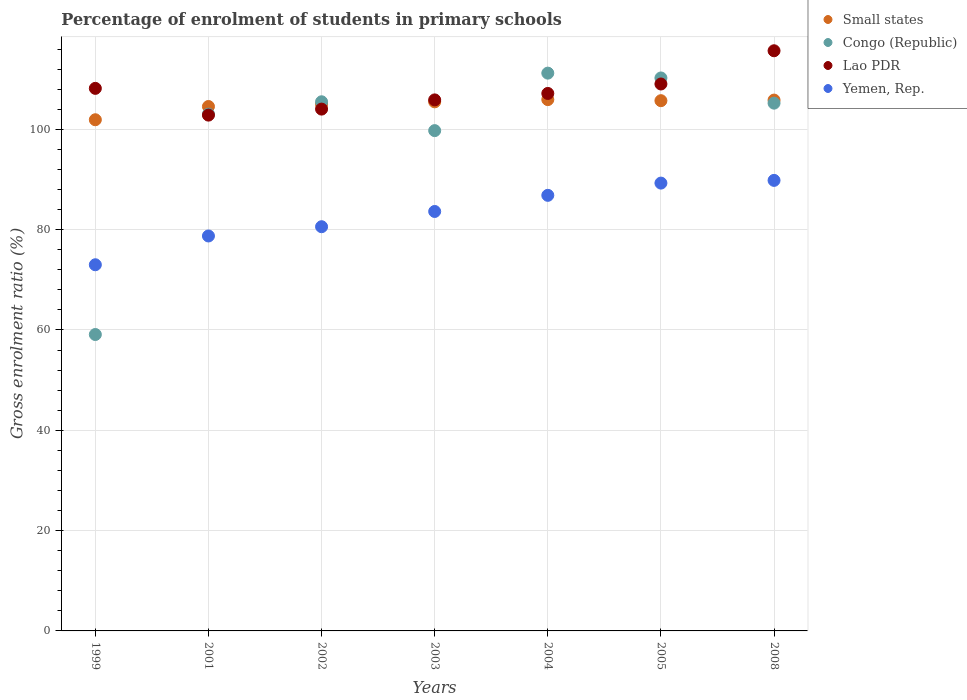Is the number of dotlines equal to the number of legend labels?
Provide a succinct answer. Yes. What is the percentage of students enrolled in primary schools in Lao PDR in 2008?
Your answer should be very brief. 115.67. Across all years, what is the maximum percentage of students enrolled in primary schools in Small states?
Provide a short and direct response. 105.93. Across all years, what is the minimum percentage of students enrolled in primary schools in Lao PDR?
Make the answer very short. 102.84. In which year was the percentage of students enrolled in primary schools in Lao PDR minimum?
Offer a very short reply. 2001. What is the total percentage of students enrolled in primary schools in Lao PDR in the graph?
Offer a very short reply. 752.82. What is the difference between the percentage of students enrolled in primary schools in Small states in 2002 and that in 2005?
Your response must be concise. -0.71. What is the difference between the percentage of students enrolled in primary schools in Congo (Republic) in 2004 and the percentage of students enrolled in primary schools in Lao PDR in 2003?
Ensure brevity in your answer.  5.34. What is the average percentage of students enrolled in primary schools in Congo (Republic) per year?
Ensure brevity in your answer.  99.16. In the year 2005, what is the difference between the percentage of students enrolled in primary schools in Lao PDR and percentage of students enrolled in primary schools in Small states?
Your response must be concise. 3.33. In how many years, is the percentage of students enrolled in primary schools in Small states greater than 24 %?
Offer a very short reply. 7. What is the ratio of the percentage of students enrolled in primary schools in Lao PDR in 2001 to that in 2005?
Keep it short and to the point. 0.94. What is the difference between the highest and the second highest percentage of students enrolled in primary schools in Small states?
Make the answer very short. 0.09. What is the difference between the highest and the lowest percentage of students enrolled in primary schools in Congo (Republic)?
Make the answer very short. 52.12. In how many years, is the percentage of students enrolled in primary schools in Small states greater than the average percentage of students enrolled in primary schools in Small states taken over all years?
Give a very brief answer. 5. Is the sum of the percentage of students enrolled in primary schools in Lao PDR in 1999 and 2001 greater than the maximum percentage of students enrolled in primary schools in Yemen, Rep. across all years?
Make the answer very short. Yes. Is it the case that in every year, the sum of the percentage of students enrolled in primary schools in Congo (Republic) and percentage of students enrolled in primary schools in Yemen, Rep.  is greater than the sum of percentage of students enrolled in primary schools in Small states and percentage of students enrolled in primary schools in Lao PDR?
Your response must be concise. No. Is it the case that in every year, the sum of the percentage of students enrolled in primary schools in Yemen, Rep. and percentage of students enrolled in primary schools in Lao PDR  is greater than the percentage of students enrolled in primary schools in Congo (Republic)?
Offer a terse response. Yes. Does the percentage of students enrolled in primary schools in Lao PDR monotonically increase over the years?
Provide a short and direct response. No. Is the percentage of students enrolled in primary schools in Congo (Republic) strictly greater than the percentage of students enrolled in primary schools in Small states over the years?
Ensure brevity in your answer.  No. What is the difference between two consecutive major ticks on the Y-axis?
Provide a succinct answer. 20. Where does the legend appear in the graph?
Make the answer very short. Top right. How many legend labels are there?
Offer a very short reply. 4. What is the title of the graph?
Keep it short and to the point. Percentage of enrolment of students in primary schools. What is the label or title of the X-axis?
Give a very brief answer. Years. What is the Gross enrolment ratio (%) in Small states in 1999?
Give a very brief answer. 101.92. What is the Gross enrolment ratio (%) in Congo (Republic) in 1999?
Keep it short and to the point. 59.1. What is the Gross enrolment ratio (%) of Lao PDR in 1999?
Keep it short and to the point. 108.18. What is the Gross enrolment ratio (%) of Yemen, Rep. in 1999?
Offer a very short reply. 73.01. What is the Gross enrolment ratio (%) of Small states in 2001?
Your answer should be compact. 104.56. What is the Gross enrolment ratio (%) in Congo (Republic) in 2001?
Give a very brief answer. 103.04. What is the Gross enrolment ratio (%) in Lao PDR in 2001?
Make the answer very short. 102.84. What is the Gross enrolment ratio (%) in Yemen, Rep. in 2001?
Provide a succinct answer. 78.75. What is the Gross enrolment ratio (%) of Small states in 2002?
Ensure brevity in your answer.  105.01. What is the Gross enrolment ratio (%) in Congo (Republic) in 2002?
Give a very brief answer. 105.5. What is the Gross enrolment ratio (%) of Lao PDR in 2002?
Offer a terse response. 104.04. What is the Gross enrolment ratio (%) in Yemen, Rep. in 2002?
Your response must be concise. 80.59. What is the Gross enrolment ratio (%) of Small states in 2003?
Keep it short and to the point. 105.49. What is the Gross enrolment ratio (%) of Congo (Republic) in 2003?
Your answer should be very brief. 99.75. What is the Gross enrolment ratio (%) of Lao PDR in 2003?
Keep it short and to the point. 105.88. What is the Gross enrolment ratio (%) of Yemen, Rep. in 2003?
Offer a very short reply. 83.63. What is the Gross enrolment ratio (%) in Small states in 2004?
Ensure brevity in your answer.  105.93. What is the Gross enrolment ratio (%) in Congo (Republic) in 2004?
Your answer should be very brief. 111.21. What is the Gross enrolment ratio (%) in Lao PDR in 2004?
Keep it short and to the point. 107.16. What is the Gross enrolment ratio (%) in Yemen, Rep. in 2004?
Keep it short and to the point. 86.85. What is the Gross enrolment ratio (%) in Small states in 2005?
Offer a very short reply. 105.72. What is the Gross enrolment ratio (%) of Congo (Republic) in 2005?
Your answer should be very brief. 110.25. What is the Gross enrolment ratio (%) of Lao PDR in 2005?
Offer a very short reply. 109.05. What is the Gross enrolment ratio (%) in Yemen, Rep. in 2005?
Make the answer very short. 89.29. What is the Gross enrolment ratio (%) in Small states in 2008?
Give a very brief answer. 105.84. What is the Gross enrolment ratio (%) in Congo (Republic) in 2008?
Give a very brief answer. 105.23. What is the Gross enrolment ratio (%) in Lao PDR in 2008?
Ensure brevity in your answer.  115.67. What is the Gross enrolment ratio (%) of Yemen, Rep. in 2008?
Keep it short and to the point. 89.83. Across all years, what is the maximum Gross enrolment ratio (%) of Small states?
Provide a short and direct response. 105.93. Across all years, what is the maximum Gross enrolment ratio (%) in Congo (Republic)?
Make the answer very short. 111.21. Across all years, what is the maximum Gross enrolment ratio (%) in Lao PDR?
Provide a succinct answer. 115.67. Across all years, what is the maximum Gross enrolment ratio (%) in Yemen, Rep.?
Provide a succinct answer. 89.83. Across all years, what is the minimum Gross enrolment ratio (%) in Small states?
Provide a short and direct response. 101.92. Across all years, what is the minimum Gross enrolment ratio (%) of Congo (Republic)?
Your response must be concise. 59.1. Across all years, what is the minimum Gross enrolment ratio (%) of Lao PDR?
Provide a short and direct response. 102.84. Across all years, what is the minimum Gross enrolment ratio (%) of Yemen, Rep.?
Ensure brevity in your answer.  73.01. What is the total Gross enrolment ratio (%) in Small states in the graph?
Offer a terse response. 734.47. What is the total Gross enrolment ratio (%) in Congo (Republic) in the graph?
Offer a very short reply. 694.09. What is the total Gross enrolment ratio (%) of Lao PDR in the graph?
Provide a short and direct response. 752.82. What is the total Gross enrolment ratio (%) of Yemen, Rep. in the graph?
Provide a short and direct response. 581.94. What is the difference between the Gross enrolment ratio (%) of Small states in 1999 and that in 2001?
Keep it short and to the point. -2.64. What is the difference between the Gross enrolment ratio (%) of Congo (Republic) in 1999 and that in 2001?
Provide a short and direct response. -43.94. What is the difference between the Gross enrolment ratio (%) of Lao PDR in 1999 and that in 2001?
Provide a short and direct response. 5.33. What is the difference between the Gross enrolment ratio (%) in Yemen, Rep. in 1999 and that in 2001?
Keep it short and to the point. -5.74. What is the difference between the Gross enrolment ratio (%) in Small states in 1999 and that in 2002?
Offer a terse response. -3.09. What is the difference between the Gross enrolment ratio (%) in Congo (Republic) in 1999 and that in 2002?
Your response must be concise. -46.4. What is the difference between the Gross enrolment ratio (%) of Lao PDR in 1999 and that in 2002?
Give a very brief answer. 4.13. What is the difference between the Gross enrolment ratio (%) in Yemen, Rep. in 1999 and that in 2002?
Provide a succinct answer. -7.58. What is the difference between the Gross enrolment ratio (%) of Small states in 1999 and that in 2003?
Offer a terse response. -3.57. What is the difference between the Gross enrolment ratio (%) in Congo (Republic) in 1999 and that in 2003?
Make the answer very short. -40.65. What is the difference between the Gross enrolment ratio (%) in Lao PDR in 1999 and that in 2003?
Your answer should be very brief. 2.3. What is the difference between the Gross enrolment ratio (%) of Yemen, Rep. in 1999 and that in 2003?
Offer a terse response. -10.62. What is the difference between the Gross enrolment ratio (%) in Small states in 1999 and that in 2004?
Your answer should be compact. -4.01. What is the difference between the Gross enrolment ratio (%) in Congo (Republic) in 1999 and that in 2004?
Offer a terse response. -52.12. What is the difference between the Gross enrolment ratio (%) in Lao PDR in 1999 and that in 2004?
Offer a terse response. 1.01. What is the difference between the Gross enrolment ratio (%) of Yemen, Rep. in 1999 and that in 2004?
Keep it short and to the point. -13.84. What is the difference between the Gross enrolment ratio (%) of Small states in 1999 and that in 2005?
Provide a short and direct response. -3.8. What is the difference between the Gross enrolment ratio (%) of Congo (Republic) in 1999 and that in 2005?
Offer a very short reply. -51.15. What is the difference between the Gross enrolment ratio (%) in Lao PDR in 1999 and that in 2005?
Your answer should be compact. -0.87. What is the difference between the Gross enrolment ratio (%) of Yemen, Rep. in 1999 and that in 2005?
Make the answer very short. -16.28. What is the difference between the Gross enrolment ratio (%) in Small states in 1999 and that in 2008?
Your response must be concise. -3.92. What is the difference between the Gross enrolment ratio (%) of Congo (Republic) in 1999 and that in 2008?
Your answer should be compact. -46.13. What is the difference between the Gross enrolment ratio (%) of Lao PDR in 1999 and that in 2008?
Give a very brief answer. -7.5. What is the difference between the Gross enrolment ratio (%) in Yemen, Rep. in 1999 and that in 2008?
Keep it short and to the point. -16.82. What is the difference between the Gross enrolment ratio (%) in Small states in 2001 and that in 2002?
Offer a very short reply. -0.45. What is the difference between the Gross enrolment ratio (%) in Congo (Republic) in 2001 and that in 2002?
Ensure brevity in your answer.  -2.46. What is the difference between the Gross enrolment ratio (%) in Lao PDR in 2001 and that in 2002?
Ensure brevity in your answer.  -1.2. What is the difference between the Gross enrolment ratio (%) in Yemen, Rep. in 2001 and that in 2002?
Provide a succinct answer. -1.84. What is the difference between the Gross enrolment ratio (%) of Small states in 2001 and that in 2003?
Ensure brevity in your answer.  -0.93. What is the difference between the Gross enrolment ratio (%) of Congo (Republic) in 2001 and that in 2003?
Give a very brief answer. 3.29. What is the difference between the Gross enrolment ratio (%) in Lao PDR in 2001 and that in 2003?
Your response must be concise. -3.04. What is the difference between the Gross enrolment ratio (%) of Yemen, Rep. in 2001 and that in 2003?
Offer a very short reply. -4.89. What is the difference between the Gross enrolment ratio (%) of Small states in 2001 and that in 2004?
Keep it short and to the point. -1.37. What is the difference between the Gross enrolment ratio (%) of Congo (Republic) in 2001 and that in 2004?
Ensure brevity in your answer.  -8.17. What is the difference between the Gross enrolment ratio (%) of Lao PDR in 2001 and that in 2004?
Provide a succinct answer. -4.32. What is the difference between the Gross enrolment ratio (%) of Yemen, Rep. in 2001 and that in 2004?
Your answer should be compact. -8.1. What is the difference between the Gross enrolment ratio (%) of Small states in 2001 and that in 2005?
Ensure brevity in your answer.  -1.16. What is the difference between the Gross enrolment ratio (%) of Congo (Republic) in 2001 and that in 2005?
Provide a succinct answer. -7.21. What is the difference between the Gross enrolment ratio (%) of Lao PDR in 2001 and that in 2005?
Make the answer very short. -6.21. What is the difference between the Gross enrolment ratio (%) in Yemen, Rep. in 2001 and that in 2005?
Make the answer very short. -10.54. What is the difference between the Gross enrolment ratio (%) in Small states in 2001 and that in 2008?
Your answer should be compact. -1.28. What is the difference between the Gross enrolment ratio (%) of Congo (Republic) in 2001 and that in 2008?
Offer a terse response. -2.19. What is the difference between the Gross enrolment ratio (%) in Lao PDR in 2001 and that in 2008?
Offer a very short reply. -12.83. What is the difference between the Gross enrolment ratio (%) in Yemen, Rep. in 2001 and that in 2008?
Keep it short and to the point. -11.08. What is the difference between the Gross enrolment ratio (%) of Small states in 2002 and that in 2003?
Make the answer very short. -0.48. What is the difference between the Gross enrolment ratio (%) in Congo (Republic) in 2002 and that in 2003?
Your answer should be very brief. 5.75. What is the difference between the Gross enrolment ratio (%) of Lao PDR in 2002 and that in 2003?
Provide a succinct answer. -1.84. What is the difference between the Gross enrolment ratio (%) in Yemen, Rep. in 2002 and that in 2003?
Make the answer very short. -3.04. What is the difference between the Gross enrolment ratio (%) of Small states in 2002 and that in 2004?
Make the answer very short. -0.93. What is the difference between the Gross enrolment ratio (%) of Congo (Republic) in 2002 and that in 2004?
Your response must be concise. -5.71. What is the difference between the Gross enrolment ratio (%) in Lao PDR in 2002 and that in 2004?
Offer a very short reply. -3.12. What is the difference between the Gross enrolment ratio (%) of Yemen, Rep. in 2002 and that in 2004?
Provide a succinct answer. -6.26. What is the difference between the Gross enrolment ratio (%) of Small states in 2002 and that in 2005?
Make the answer very short. -0.71. What is the difference between the Gross enrolment ratio (%) of Congo (Republic) in 2002 and that in 2005?
Your answer should be very brief. -4.75. What is the difference between the Gross enrolment ratio (%) in Lao PDR in 2002 and that in 2005?
Your answer should be very brief. -5.01. What is the difference between the Gross enrolment ratio (%) of Yemen, Rep. in 2002 and that in 2005?
Make the answer very short. -8.7. What is the difference between the Gross enrolment ratio (%) of Small states in 2002 and that in 2008?
Make the answer very short. -0.83. What is the difference between the Gross enrolment ratio (%) of Congo (Republic) in 2002 and that in 2008?
Ensure brevity in your answer.  0.27. What is the difference between the Gross enrolment ratio (%) in Lao PDR in 2002 and that in 2008?
Keep it short and to the point. -11.63. What is the difference between the Gross enrolment ratio (%) of Yemen, Rep. in 2002 and that in 2008?
Keep it short and to the point. -9.24. What is the difference between the Gross enrolment ratio (%) in Small states in 2003 and that in 2004?
Give a very brief answer. -0.44. What is the difference between the Gross enrolment ratio (%) of Congo (Republic) in 2003 and that in 2004?
Your answer should be compact. -11.46. What is the difference between the Gross enrolment ratio (%) in Lao PDR in 2003 and that in 2004?
Your answer should be very brief. -1.29. What is the difference between the Gross enrolment ratio (%) of Yemen, Rep. in 2003 and that in 2004?
Provide a short and direct response. -3.22. What is the difference between the Gross enrolment ratio (%) in Small states in 2003 and that in 2005?
Keep it short and to the point. -0.23. What is the difference between the Gross enrolment ratio (%) of Congo (Republic) in 2003 and that in 2005?
Your answer should be very brief. -10.5. What is the difference between the Gross enrolment ratio (%) of Lao PDR in 2003 and that in 2005?
Your answer should be very brief. -3.17. What is the difference between the Gross enrolment ratio (%) in Yemen, Rep. in 2003 and that in 2005?
Give a very brief answer. -5.66. What is the difference between the Gross enrolment ratio (%) of Small states in 2003 and that in 2008?
Keep it short and to the point. -0.35. What is the difference between the Gross enrolment ratio (%) in Congo (Republic) in 2003 and that in 2008?
Ensure brevity in your answer.  -5.48. What is the difference between the Gross enrolment ratio (%) in Lao PDR in 2003 and that in 2008?
Make the answer very short. -9.8. What is the difference between the Gross enrolment ratio (%) in Yemen, Rep. in 2003 and that in 2008?
Offer a very short reply. -6.2. What is the difference between the Gross enrolment ratio (%) in Small states in 2004 and that in 2005?
Your response must be concise. 0.21. What is the difference between the Gross enrolment ratio (%) of Congo (Republic) in 2004 and that in 2005?
Keep it short and to the point. 0.96. What is the difference between the Gross enrolment ratio (%) of Lao PDR in 2004 and that in 2005?
Your answer should be compact. -1.88. What is the difference between the Gross enrolment ratio (%) in Yemen, Rep. in 2004 and that in 2005?
Give a very brief answer. -2.44. What is the difference between the Gross enrolment ratio (%) of Small states in 2004 and that in 2008?
Provide a short and direct response. 0.09. What is the difference between the Gross enrolment ratio (%) of Congo (Republic) in 2004 and that in 2008?
Your answer should be very brief. 5.98. What is the difference between the Gross enrolment ratio (%) of Lao PDR in 2004 and that in 2008?
Offer a very short reply. -8.51. What is the difference between the Gross enrolment ratio (%) of Yemen, Rep. in 2004 and that in 2008?
Your response must be concise. -2.98. What is the difference between the Gross enrolment ratio (%) of Small states in 2005 and that in 2008?
Give a very brief answer. -0.12. What is the difference between the Gross enrolment ratio (%) of Congo (Republic) in 2005 and that in 2008?
Your answer should be very brief. 5.02. What is the difference between the Gross enrolment ratio (%) in Lao PDR in 2005 and that in 2008?
Offer a very short reply. -6.63. What is the difference between the Gross enrolment ratio (%) in Yemen, Rep. in 2005 and that in 2008?
Keep it short and to the point. -0.54. What is the difference between the Gross enrolment ratio (%) of Small states in 1999 and the Gross enrolment ratio (%) of Congo (Republic) in 2001?
Give a very brief answer. -1.12. What is the difference between the Gross enrolment ratio (%) of Small states in 1999 and the Gross enrolment ratio (%) of Lao PDR in 2001?
Give a very brief answer. -0.92. What is the difference between the Gross enrolment ratio (%) in Small states in 1999 and the Gross enrolment ratio (%) in Yemen, Rep. in 2001?
Provide a succinct answer. 23.17. What is the difference between the Gross enrolment ratio (%) in Congo (Republic) in 1999 and the Gross enrolment ratio (%) in Lao PDR in 2001?
Provide a succinct answer. -43.74. What is the difference between the Gross enrolment ratio (%) of Congo (Republic) in 1999 and the Gross enrolment ratio (%) of Yemen, Rep. in 2001?
Offer a terse response. -19.65. What is the difference between the Gross enrolment ratio (%) in Lao PDR in 1999 and the Gross enrolment ratio (%) in Yemen, Rep. in 2001?
Make the answer very short. 29.43. What is the difference between the Gross enrolment ratio (%) of Small states in 1999 and the Gross enrolment ratio (%) of Congo (Republic) in 2002?
Provide a succinct answer. -3.58. What is the difference between the Gross enrolment ratio (%) of Small states in 1999 and the Gross enrolment ratio (%) of Lao PDR in 2002?
Offer a terse response. -2.12. What is the difference between the Gross enrolment ratio (%) in Small states in 1999 and the Gross enrolment ratio (%) in Yemen, Rep. in 2002?
Your answer should be compact. 21.33. What is the difference between the Gross enrolment ratio (%) in Congo (Republic) in 1999 and the Gross enrolment ratio (%) in Lao PDR in 2002?
Offer a terse response. -44.94. What is the difference between the Gross enrolment ratio (%) in Congo (Republic) in 1999 and the Gross enrolment ratio (%) in Yemen, Rep. in 2002?
Provide a succinct answer. -21.49. What is the difference between the Gross enrolment ratio (%) in Lao PDR in 1999 and the Gross enrolment ratio (%) in Yemen, Rep. in 2002?
Your answer should be compact. 27.59. What is the difference between the Gross enrolment ratio (%) of Small states in 1999 and the Gross enrolment ratio (%) of Congo (Republic) in 2003?
Offer a very short reply. 2.17. What is the difference between the Gross enrolment ratio (%) in Small states in 1999 and the Gross enrolment ratio (%) in Lao PDR in 2003?
Give a very brief answer. -3.96. What is the difference between the Gross enrolment ratio (%) of Small states in 1999 and the Gross enrolment ratio (%) of Yemen, Rep. in 2003?
Offer a very short reply. 18.29. What is the difference between the Gross enrolment ratio (%) of Congo (Republic) in 1999 and the Gross enrolment ratio (%) of Lao PDR in 2003?
Your response must be concise. -46.78. What is the difference between the Gross enrolment ratio (%) in Congo (Republic) in 1999 and the Gross enrolment ratio (%) in Yemen, Rep. in 2003?
Offer a terse response. -24.53. What is the difference between the Gross enrolment ratio (%) of Lao PDR in 1999 and the Gross enrolment ratio (%) of Yemen, Rep. in 2003?
Make the answer very short. 24.55. What is the difference between the Gross enrolment ratio (%) of Small states in 1999 and the Gross enrolment ratio (%) of Congo (Republic) in 2004?
Your answer should be very brief. -9.29. What is the difference between the Gross enrolment ratio (%) in Small states in 1999 and the Gross enrolment ratio (%) in Lao PDR in 2004?
Offer a very short reply. -5.25. What is the difference between the Gross enrolment ratio (%) of Small states in 1999 and the Gross enrolment ratio (%) of Yemen, Rep. in 2004?
Make the answer very short. 15.07. What is the difference between the Gross enrolment ratio (%) in Congo (Republic) in 1999 and the Gross enrolment ratio (%) in Lao PDR in 2004?
Your response must be concise. -48.07. What is the difference between the Gross enrolment ratio (%) in Congo (Republic) in 1999 and the Gross enrolment ratio (%) in Yemen, Rep. in 2004?
Your response must be concise. -27.75. What is the difference between the Gross enrolment ratio (%) of Lao PDR in 1999 and the Gross enrolment ratio (%) of Yemen, Rep. in 2004?
Offer a very short reply. 21.33. What is the difference between the Gross enrolment ratio (%) of Small states in 1999 and the Gross enrolment ratio (%) of Congo (Republic) in 2005?
Provide a short and direct response. -8.33. What is the difference between the Gross enrolment ratio (%) in Small states in 1999 and the Gross enrolment ratio (%) in Lao PDR in 2005?
Provide a succinct answer. -7.13. What is the difference between the Gross enrolment ratio (%) in Small states in 1999 and the Gross enrolment ratio (%) in Yemen, Rep. in 2005?
Offer a very short reply. 12.63. What is the difference between the Gross enrolment ratio (%) of Congo (Republic) in 1999 and the Gross enrolment ratio (%) of Lao PDR in 2005?
Keep it short and to the point. -49.95. What is the difference between the Gross enrolment ratio (%) in Congo (Republic) in 1999 and the Gross enrolment ratio (%) in Yemen, Rep. in 2005?
Your answer should be very brief. -30.19. What is the difference between the Gross enrolment ratio (%) in Lao PDR in 1999 and the Gross enrolment ratio (%) in Yemen, Rep. in 2005?
Your answer should be very brief. 18.89. What is the difference between the Gross enrolment ratio (%) of Small states in 1999 and the Gross enrolment ratio (%) of Congo (Republic) in 2008?
Your answer should be compact. -3.31. What is the difference between the Gross enrolment ratio (%) in Small states in 1999 and the Gross enrolment ratio (%) in Lao PDR in 2008?
Provide a succinct answer. -13.75. What is the difference between the Gross enrolment ratio (%) in Small states in 1999 and the Gross enrolment ratio (%) in Yemen, Rep. in 2008?
Ensure brevity in your answer.  12.09. What is the difference between the Gross enrolment ratio (%) of Congo (Republic) in 1999 and the Gross enrolment ratio (%) of Lao PDR in 2008?
Offer a terse response. -56.58. What is the difference between the Gross enrolment ratio (%) of Congo (Republic) in 1999 and the Gross enrolment ratio (%) of Yemen, Rep. in 2008?
Keep it short and to the point. -30.73. What is the difference between the Gross enrolment ratio (%) in Lao PDR in 1999 and the Gross enrolment ratio (%) in Yemen, Rep. in 2008?
Keep it short and to the point. 18.35. What is the difference between the Gross enrolment ratio (%) of Small states in 2001 and the Gross enrolment ratio (%) of Congo (Republic) in 2002?
Provide a succinct answer. -0.94. What is the difference between the Gross enrolment ratio (%) of Small states in 2001 and the Gross enrolment ratio (%) of Lao PDR in 2002?
Make the answer very short. 0.52. What is the difference between the Gross enrolment ratio (%) of Small states in 2001 and the Gross enrolment ratio (%) of Yemen, Rep. in 2002?
Provide a short and direct response. 23.97. What is the difference between the Gross enrolment ratio (%) in Congo (Republic) in 2001 and the Gross enrolment ratio (%) in Lao PDR in 2002?
Provide a succinct answer. -1. What is the difference between the Gross enrolment ratio (%) in Congo (Republic) in 2001 and the Gross enrolment ratio (%) in Yemen, Rep. in 2002?
Provide a succinct answer. 22.45. What is the difference between the Gross enrolment ratio (%) of Lao PDR in 2001 and the Gross enrolment ratio (%) of Yemen, Rep. in 2002?
Offer a very short reply. 22.25. What is the difference between the Gross enrolment ratio (%) of Small states in 2001 and the Gross enrolment ratio (%) of Congo (Republic) in 2003?
Provide a succinct answer. 4.81. What is the difference between the Gross enrolment ratio (%) in Small states in 2001 and the Gross enrolment ratio (%) in Lao PDR in 2003?
Your response must be concise. -1.32. What is the difference between the Gross enrolment ratio (%) in Small states in 2001 and the Gross enrolment ratio (%) in Yemen, Rep. in 2003?
Keep it short and to the point. 20.93. What is the difference between the Gross enrolment ratio (%) in Congo (Republic) in 2001 and the Gross enrolment ratio (%) in Lao PDR in 2003?
Your answer should be compact. -2.84. What is the difference between the Gross enrolment ratio (%) in Congo (Republic) in 2001 and the Gross enrolment ratio (%) in Yemen, Rep. in 2003?
Ensure brevity in your answer.  19.41. What is the difference between the Gross enrolment ratio (%) in Lao PDR in 2001 and the Gross enrolment ratio (%) in Yemen, Rep. in 2003?
Offer a terse response. 19.21. What is the difference between the Gross enrolment ratio (%) in Small states in 2001 and the Gross enrolment ratio (%) in Congo (Republic) in 2004?
Provide a succinct answer. -6.65. What is the difference between the Gross enrolment ratio (%) of Small states in 2001 and the Gross enrolment ratio (%) of Lao PDR in 2004?
Provide a short and direct response. -2.6. What is the difference between the Gross enrolment ratio (%) of Small states in 2001 and the Gross enrolment ratio (%) of Yemen, Rep. in 2004?
Make the answer very short. 17.71. What is the difference between the Gross enrolment ratio (%) of Congo (Republic) in 2001 and the Gross enrolment ratio (%) of Lao PDR in 2004?
Offer a very short reply. -4.13. What is the difference between the Gross enrolment ratio (%) in Congo (Republic) in 2001 and the Gross enrolment ratio (%) in Yemen, Rep. in 2004?
Give a very brief answer. 16.19. What is the difference between the Gross enrolment ratio (%) of Lao PDR in 2001 and the Gross enrolment ratio (%) of Yemen, Rep. in 2004?
Give a very brief answer. 15.99. What is the difference between the Gross enrolment ratio (%) in Small states in 2001 and the Gross enrolment ratio (%) in Congo (Republic) in 2005?
Your response must be concise. -5.69. What is the difference between the Gross enrolment ratio (%) in Small states in 2001 and the Gross enrolment ratio (%) in Lao PDR in 2005?
Make the answer very short. -4.49. What is the difference between the Gross enrolment ratio (%) in Small states in 2001 and the Gross enrolment ratio (%) in Yemen, Rep. in 2005?
Provide a succinct answer. 15.27. What is the difference between the Gross enrolment ratio (%) of Congo (Republic) in 2001 and the Gross enrolment ratio (%) of Lao PDR in 2005?
Give a very brief answer. -6.01. What is the difference between the Gross enrolment ratio (%) in Congo (Republic) in 2001 and the Gross enrolment ratio (%) in Yemen, Rep. in 2005?
Your answer should be very brief. 13.75. What is the difference between the Gross enrolment ratio (%) in Lao PDR in 2001 and the Gross enrolment ratio (%) in Yemen, Rep. in 2005?
Provide a succinct answer. 13.55. What is the difference between the Gross enrolment ratio (%) in Small states in 2001 and the Gross enrolment ratio (%) in Congo (Republic) in 2008?
Provide a short and direct response. -0.67. What is the difference between the Gross enrolment ratio (%) in Small states in 2001 and the Gross enrolment ratio (%) in Lao PDR in 2008?
Your answer should be very brief. -11.11. What is the difference between the Gross enrolment ratio (%) of Small states in 2001 and the Gross enrolment ratio (%) of Yemen, Rep. in 2008?
Offer a terse response. 14.73. What is the difference between the Gross enrolment ratio (%) in Congo (Republic) in 2001 and the Gross enrolment ratio (%) in Lao PDR in 2008?
Offer a terse response. -12.63. What is the difference between the Gross enrolment ratio (%) in Congo (Republic) in 2001 and the Gross enrolment ratio (%) in Yemen, Rep. in 2008?
Provide a short and direct response. 13.21. What is the difference between the Gross enrolment ratio (%) in Lao PDR in 2001 and the Gross enrolment ratio (%) in Yemen, Rep. in 2008?
Ensure brevity in your answer.  13.01. What is the difference between the Gross enrolment ratio (%) in Small states in 2002 and the Gross enrolment ratio (%) in Congo (Republic) in 2003?
Your answer should be compact. 5.26. What is the difference between the Gross enrolment ratio (%) in Small states in 2002 and the Gross enrolment ratio (%) in Lao PDR in 2003?
Your response must be concise. -0.87. What is the difference between the Gross enrolment ratio (%) of Small states in 2002 and the Gross enrolment ratio (%) of Yemen, Rep. in 2003?
Offer a terse response. 21.38. What is the difference between the Gross enrolment ratio (%) in Congo (Republic) in 2002 and the Gross enrolment ratio (%) in Lao PDR in 2003?
Your response must be concise. -0.38. What is the difference between the Gross enrolment ratio (%) in Congo (Republic) in 2002 and the Gross enrolment ratio (%) in Yemen, Rep. in 2003?
Offer a very short reply. 21.87. What is the difference between the Gross enrolment ratio (%) in Lao PDR in 2002 and the Gross enrolment ratio (%) in Yemen, Rep. in 2003?
Provide a short and direct response. 20.41. What is the difference between the Gross enrolment ratio (%) in Small states in 2002 and the Gross enrolment ratio (%) in Congo (Republic) in 2004?
Give a very brief answer. -6.21. What is the difference between the Gross enrolment ratio (%) in Small states in 2002 and the Gross enrolment ratio (%) in Lao PDR in 2004?
Make the answer very short. -2.16. What is the difference between the Gross enrolment ratio (%) in Small states in 2002 and the Gross enrolment ratio (%) in Yemen, Rep. in 2004?
Ensure brevity in your answer.  18.16. What is the difference between the Gross enrolment ratio (%) in Congo (Republic) in 2002 and the Gross enrolment ratio (%) in Lao PDR in 2004?
Your answer should be very brief. -1.66. What is the difference between the Gross enrolment ratio (%) in Congo (Republic) in 2002 and the Gross enrolment ratio (%) in Yemen, Rep. in 2004?
Your response must be concise. 18.65. What is the difference between the Gross enrolment ratio (%) of Lao PDR in 2002 and the Gross enrolment ratio (%) of Yemen, Rep. in 2004?
Keep it short and to the point. 17.19. What is the difference between the Gross enrolment ratio (%) in Small states in 2002 and the Gross enrolment ratio (%) in Congo (Republic) in 2005?
Make the answer very short. -5.24. What is the difference between the Gross enrolment ratio (%) of Small states in 2002 and the Gross enrolment ratio (%) of Lao PDR in 2005?
Offer a very short reply. -4.04. What is the difference between the Gross enrolment ratio (%) of Small states in 2002 and the Gross enrolment ratio (%) of Yemen, Rep. in 2005?
Provide a succinct answer. 15.72. What is the difference between the Gross enrolment ratio (%) in Congo (Republic) in 2002 and the Gross enrolment ratio (%) in Lao PDR in 2005?
Make the answer very short. -3.55. What is the difference between the Gross enrolment ratio (%) of Congo (Republic) in 2002 and the Gross enrolment ratio (%) of Yemen, Rep. in 2005?
Give a very brief answer. 16.21. What is the difference between the Gross enrolment ratio (%) in Lao PDR in 2002 and the Gross enrolment ratio (%) in Yemen, Rep. in 2005?
Make the answer very short. 14.75. What is the difference between the Gross enrolment ratio (%) in Small states in 2002 and the Gross enrolment ratio (%) in Congo (Republic) in 2008?
Provide a succinct answer. -0.22. What is the difference between the Gross enrolment ratio (%) in Small states in 2002 and the Gross enrolment ratio (%) in Lao PDR in 2008?
Give a very brief answer. -10.67. What is the difference between the Gross enrolment ratio (%) in Small states in 2002 and the Gross enrolment ratio (%) in Yemen, Rep. in 2008?
Provide a short and direct response. 15.18. What is the difference between the Gross enrolment ratio (%) in Congo (Republic) in 2002 and the Gross enrolment ratio (%) in Lao PDR in 2008?
Offer a terse response. -10.17. What is the difference between the Gross enrolment ratio (%) in Congo (Republic) in 2002 and the Gross enrolment ratio (%) in Yemen, Rep. in 2008?
Give a very brief answer. 15.67. What is the difference between the Gross enrolment ratio (%) of Lao PDR in 2002 and the Gross enrolment ratio (%) of Yemen, Rep. in 2008?
Offer a terse response. 14.21. What is the difference between the Gross enrolment ratio (%) of Small states in 2003 and the Gross enrolment ratio (%) of Congo (Republic) in 2004?
Your answer should be very brief. -5.72. What is the difference between the Gross enrolment ratio (%) in Small states in 2003 and the Gross enrolment ratio (%) in Lao PDR in 2004?
Give a very brief answer. -1.67. What is the difference between the Gross enrolment ratio (%) of Small states in 2003 and the Gross enrolment ratio (%) of Yemen, Rep. in 2004?
Your response must be concise. 18.64. What is the difference between the Gross enrolment ratio (%) in Congo (Republic) in 2003 and the Gross enrolment ratio (%) in Lao PDR in 2004?
Your answer should be compact. -7.41. What is the difference between the Gross enrolment ratio (%) in Congo (Republic) in 2003 and the Gross enrolment ratio (%) in Yemen, Rep. in 2004?
Give a very brief answer. 12.9. What is the difference between the Gross enrolment ratio (%) in Lao PDR in 2003 and the Gross enrolment ratio (%) in Yemen, Rep. in 2004?
Your answer should be very brief. 19.03. What is the difference between the Gross enrolment ratio (%) of Small states in 2003 and the Gross enrolment ratio (%) of Congo (Republic) in 2005?
Offer a terse response. -4.76. What is the difference between the Gross enrolment ratio (%) of Small states in 2003 and the Gross enrolment ratio (%) of Lao PDR in 2005?
Your answer should be compact. -3.56. What is the difference between the Gross enrolment ratio (%) in Small states in 2003 and the Gross enrolment ratio (%) in Yemen, Rep. in 2005?
Ensure brevity in your answer.  16.2. What is the difference between the Gross enrolment ratio (%) in Congo (Republic) in 2003 and the Gross enrolment ratio (%) in Lao PDR in 2005?
Offer a terse response. -9.3. What is the difference between the Gross enrolment ratio (%) in Congo (Republic) in 2003 and the Gross enrolment ratio (%) in Yemen, Rep. in 2005?
Offer a very short reply. 10.46. What is the difference between the Gross enrolment ratio (%) in Lao PDR in 2003 and the Gross enrolment ratio (%) in Yemen, Rep. in 2005?
Your response must be concise. 16.59. What is the difference between the Gross enrolment ratio (%) in Small states in 2003 and the Gross enrolment ratio (%) in Congo (Republic) in 2008?
Offer a very short reply. 0.26. What is the difference between the Gross enrolment ratio (%) of Small states in 2003 and the Gross enrolment ratio (%) of Lao PDR in 2008?
Ensure brevity in your answer.  -10.18. What is the difference between the Gross enrolment ratio (%) in Small states in 2003 and the Gross enrolment ratio (%) in Yemen, Rep. in 2008?
Offer a terse response. 15.66. What is the difference between the Gross enrolment ratio (%) in Congo (Republic) in 2003 and the Gross enrolment ratio (%) in Lao PDR in 2008?
Your response must be concise. -15.92. What is the difference between the Gross enrolment ratio (%) of Congo (Republic) in 2003 and the Gross enrolment ratio (%) of Yemen, Rep. in 2008?
Provide a succinct answer. 9.92. What is the difference between the Gross enrolment ratio (%) of Lao PDR in 2003 and the Gross enrolment ratio (%) of Yemen, Rep. in 2008?
Provide a succinct answer. 16.05. What is the difference between the Gross enrolment ratio (%) in Small states in 2004 and the Gross enrolment ratio (%) in Congo (Republic) in 2005?
Offer a terse response. -4.32. What is the difference between the Gross enrolment ratio (%) in Small states in 2004 and the Gross enrolment ratio (%) in Lao PDR in 2005?
Offer a very short reply. -3.11. What is the difference between the Gross enrolment ratio (%) of Small states in 2004 and the Gross enrolment ratio (%) of Yemen, Rep. in 2005?
Ensure brevity in your answer.  16.65. What is the difference between the Gross enrolment ratio (%) in Congo (Republic) in 2004 and the Gross enrolment ratio (%) in Lao PDR in 2005?
Provide a short and direct response. 2.17. What is the difference between the Gross enrolment ratio (%) of Congo (Republic) in 2004 and the Gross enrolment ratio (%) of Yemen, Rep. in 2005?
Make the answer very short. 21.93. What is the difference between the Gross enrolment ratio (%) in Lao PDR in 2004 and the Gross enrolment ratio (%) in Yemen, Rep. in 2005?
Offer a terse response. 17.88. What is the difference between the Gross enrolment ratio (%) in Small states in 2004 and the Gross enrolment ratio (%) in Congo (Republic) in 2008?
Ensure brevity in your answer.  0.71. What is the difference between the Gross enrolment ratio (%) in Small states in 2004 and the Gross enrolment ratio (%) in Lao PDR in 2008?
Offer a terse response. -9.74. What is the difference between the Gross enrolment ratio (%) of Small states in 2004 and the Gross enrolment ratio (%) of Yemen, Rep. in 2008?
Keep it short and to the point. 16.1. What is the difference between the Gross enrolment ratio (%) in Congo (Republic) in 2004 and the Gross enrolment ratio (%) in Lao PDR in 2008?
Provide a short and direct response. -4.46. What is the difference between the Gross enrolment ratio (%) in Congo (Republic) in 2004 and the Gross enrolment ratio (%) in Yemen, Rep. in 2008?
Make the answer very short. 21.38. What is the difference between the Gross enrolment ratio (%) of Lao PDR in 2004 and the Gross enrolment ratio (%) of Yemen, Rep. in 2008?
Keep it short and to the point. 17.34. What is the difference between the Gross enrolment ratio (%) in Small states in 2005 and the Gross enrolment ratio (%) in Congo (Republic) in 2008?
Give a very brief answer. 0.49. What is the difference between the Gross enrolment ratio (%) of Small states in 2005 and the Gross enrolment ratio (%) of Lao PDR in 2008?
Your answer should be very brief. -9.95. What is the difference between the Gross enrolment ratio (%) of Small states in 2005 and the Gross enrolment ratio (%) of Yemen, Rep. in 2008?
Your answer should be very brief. 15.89. What is the difference between the Gross enrolment ratio (%) in Congo (Republic) in 2005 and the Gross enrolment ratio (%) in Lao PDR in 2008?
Provide a short and direct response. -5.42. What is the difference between the Gross enrolment ratio (%) of Congo (Republic) in 2005 and the Gross enrolment ratio (%) of Yemen, Rep. in 2008?
Provide a succinct answer. 20.42. What is the difference between the Gross enrolment ratio (%) in Lao PDR in 2005 and the Gross enrolment ratio (%) in Yemen, Rep. in 2008?
Offer a very short reply. 19.22. What is the average Gross enrolment ratio (%) in Small states per year?
Your response must be concise. 104.92. What is the average Gross enrolment ratio (%) of Congo (Republic) per year?
Give a very brief answer. 99.16. What is the average Gross enrolment ratio (%) of Lao PDR per year?
Give a very brief answer. 107.55. What is the average Gross enrolment ratio (%) in Yemen, Rep. per year?
Keep it short and to the point. 83.13. In the year 1999, what is the difference between the Gross enrolment ratio (%) of Small states and Gross enrolment ratio (%) of Congo (Republic)?
Offer a very short reply. 42.82. In the year 1999, what is the difference between the Gross enrolment ratio (%) in Small states and Gross enrolment ratio (%) in Lao PDR?
Give a very brief answer. -6.26. In the year 1999, what is the difference between the Gross enrolment ratio (%) of Small states and Gross enrolment ratio (%) of Yemen, Rep.?
Provide a short and direct response. 28.91. In the year 1999, what is the difference between the Gross enrolment ratio (%) in Congo (Republic) and Gross enrolment ratio (%) in Lao PDR?
Make the answer very short. -49.08. In the year 1999, what is the difference between the Gross enrolment ratio (%) of Congo (Republic) and Gross enrolment ratio (%) of Yemen, Rep.?
Keep it short and to the point. -13.91. In the year 1999, what is the difference between the Gross enrolment ratio (%) of Lao PDR and Gross enrolment ratio (%) of Yemen, Rep.?
Make the answer very short. 35.17. In the year 2001, what is the difference between the Gross enrolment ratio (%) of Small states and Gross enrolment ratio (%) of Congo (Republic)?
Give a very brief answer. 1.52. In the year 2001, what is the difference between the Gross enrolment ratio (%) of Small states and Gross enrolment ratio (%) of Lao PDR?
Your answer should be very brief. 1.72. In the year 2001, what is the difference between the Gross enrolment ratio (%) of Small states and Gross enrolment ratio (%) of Yemen, Rep.?
Your answer should be very brief. 25.81. In the year 2001, what is the difference between the Gross enrolment ratio (%) in Congo (Republic) and Gross enrolment ratio (%) in Lao PDR?
Provide a short and direct response. 0.2. In the year 2001, what is the difference between the Gross enrolment ratio (%) of Congo (Republic) and Gross enrolment ratio (%) of Yemen, Rep.?
Ensure brevity in your answer.  24.29. In the year 2001, what is the difference between the Gross enrolment ratio (%) in Lao PDR and Gross enrolment ratio (%) in Yemen, Rep.?
Keep it short and to the point. 24.1. In the year 2002, what is the difference between the Gross enrolment ratio (%) in Small states and Gross enrolment ratio (%) in Congo (Republic)?
Give a very brief answer. -0.49. In the year 2002, what is the difference between the Gross enrolment ratio (%) in Small states and Gross enrolment ratio (%) in Lao PDR?
Your response must be concise. 0.97. In the year 2002, what is the difference between the Gross enrolment ratio (%) of Small states and Gross enrolment ratio (%) of Yemen, Rep.?
Provide a succinct answer. 24.42. In the year 2002, what is the difference between the Gross enrolment ratio (%) in Congo (Republic) and Gross enrolment ratio (%) in Lao PDR?
Give a very brief answer. 1.46. In the year 2002, what is the difference between the Gross enrolment ratio (%) of Congo (Republic) and Gross enrolment ratio (%) of Yemen, Rep.?
Keep it short and to the point. 24.91. In the year 2002, what is the difference between the Gross enrolment ratio (%) of Lao PDR and Gross enrolment ratio (%) of Yemen, Rep.?
Give a very brief answer. 23.45. In the year 2003, what is the difference between the Gross enrolment ratio (%) in Small states and Gross enrolment ratio (%) in Congo (Republic)?
Make the answer very short. 5.74. In the year 2003, what is the difference between the Gross enrolment ratio (%) in Small states and Gross enrolment ratio (%) in Lao PDR?
Keep it short and to the point. -0.39. In the year 2003, what is the difference between the Gross enrolment ratio (%) of Small states and Gross enrolment ratio (%) of Yemen, Rep.?
Offer a terse response. 21.86. In the year 2003, what is the difference between the Gross enrolment ratio (%) of Congo (Republic) and Gross enrolment ratio (%) of Lao PDR?
Make the answer very short. -6.13. In the year 2003, what is the difference between the Gross enrolment ratio (%) of Congo (Republic) and Gross enrolment ratio (%) of Yemen, Rep.?
Provide a short and direct response. 16.12. In the year 2003, what is the difference between the Gross enrolment ratio (%) of Lao PDR and Gross enrolment ratio (%) of Yemen, Rep.?
Your answer should be compact. 22.25. In the year 2004, what is the difference between the Gross enrolment ratio (%) in Small states and Gross enrolment ratio (%) in Congo (Republic)?
Offer a terse response. -5.28. In the year 2004, what is the difference between the Gross enrolment ratio (%) in Small states and Gross enrolment ratio (%) in Lao PDR?
Offer a terse response. -1.23. In the year 2004, what is the difference between the Gross enrolment ratio (%) of Small states and Gross enrolment ratio (%) of Yemen, Rep.?
Provide a short and direct response. 19.08. In the year 2004, what is the difference between the Gross enrolment ratio (%) of Congo (Republic) and Gross enrolment ratio (%) of Lao PDR?
Offer a very short reply. 4.05. In the year 2004, what is the difference between the Gross enrolment ratio (%) in Congo (Republic) and Gross enrolment ratio (%) in Yemen, Rep.?
Keep it short and to the point. 24.36. In the year 2004, what is the difference between the Gross enrolment ratio (%) in Lao PDR and Gross enrolment ratio (%) in Yemen, Rep.?
Provide a short and direct response. 20.32. In the year 2005, what is the difference between the Gross enrolment ratio (%) of Small states and Gross enrolment ratio (%) of Congo (Republic)?
Provide a short and direct response. -4.53. In the year 2005, what is the difference between the Gross enrolment ratio (%) in Small states and Gross enrolment ratio (%) in Lao PDR?
Keep it short and to the point. -3.33. In the year 2005, what is the difference between the Gross enrolment ratio (%) in Small states and Gross enrolment ratio (%) in Yemen, Rep.?
Ensure brevity in your answer.  16.43. In the year 2005, what is the difference between the Gross enrolment ratio (%) of Congo (Republic) and Gross enrolment ratio (%) of Lao PDR?
Provide a short and direct response. 1.2. In the year 2005, what is the difference between the Gross enrolment ratio (%) of Congo (Republic) and Gross enrolment ratio (%) of Yemen, Rep.?
Your answer should be compact. 20.96. In the year 2005, what is the difference between the Gross enrolment ratio (%) of Lao PDR and Gross enrolment ratio (%) of Yemen, Rep.?
Offer a very short reply. 19.76. In the year 2008, what is the difference between the Gross enrolment ratio (%) in Small states and Gross enrolment ratio (%) in Congo (Republic)?
Offer a terse response. 0.61. In the year 2008, what is the difference between the Gross enrolment ratio (%) in Small states and Gross enrolment ratio (%) in Lao PDR?
Ensure brevity in your answer.  -9.83. In the year 2008, what is the difference between the Gross enrolment ratio (%) in Small states and Gross enrolment ratio (%) in Yemen, Rep.?
Your answer should be very brief. 16.01. In the year 2008, what is the difference between the Gross enrolment ratio (%) in Congo (Republic) and Gross enrolment ratio (%) in Lao PDR?
Offer a very short reply. -10.45. In the year 2008, what is the difference between the Gross enrolment ratio (%) of Congo (Republic) and Gross enrolment ratio (%) of Yemen, Rep.?
Ensure brevity in your answer.  15.4. In the year 2008, what is the difference between the Gross enrolment ratio (%) in Lao PDR and Gross enrolment ratio (%) in Yemen, Rep.?
Ensure brevity in your answer.  25.84. What is the ratio of the Gross enrolment ratio (%) in Small states in 1999 to that in 2001?
Provide a short and direct response. 0.97. What is the ratio of the Gross enrolment ratio (%) in Congo (Republic) in 1999 to that in 2001?
Offer a terse response. 0.57. What is the ratio of the Gross enrolment ratio (%) in Lao PDR in 1999 to that in 2001?
Your answer should be very brief. 1.05. What is the ratio of the Gross enrolment ratio (%) in Yemen, Rep. in 1999 to that in 2001?
Give a very brief answer. 0.93. What is the ratio of the Gross enrolment ratio (%) of Small states in 1999 to that in 2002?
Offer a very short reply. 0.97. What is the ratio of the Gross enrolment ratio (%) in Congo (Republic) in 1999 to that in 2002?
Make the answer very short. 0.56. What is the ratio of the Gross enrolment ratio (%) in Lao PDR in 1999 to that in 2002?
Provide a succinct answer. 1.04. What is the ratio of the Gross enrolment ratio (%) of Yemen, Rep. in 1999 to that in 2002?
Your answer should be very brief. 0.91. What is the ratio of the Gross enrolment ratio (%) of Small states in 1999 to that in 2003?
Provide a succinct answer. 0.97. What is the ratio of the Gross enrolment ratio (%) in Congo (Republic) in 1999 to that in 2003?
Offer a terse response. 0.59. What is the ratio of the Gross enrolment ratio (%) in Lao PDR in 1999 to that in 2003?
Provide a succinct answer. 1.02. What is the ratio of the Gross enrolment ratio (%) of Yemen, Rep. in 1999 to that in 2003?
Your response must be concise. 0.87. What is the ratio of the Gross enrolment ratio (%) of Small states in 1999 to that in 2004?
Give a very brief answer. 0.96. What is the ratio of the Gross enrolment ratio (%) of Congo (Republic) in 1999 to that in 2004?
Keep it short and to the point. 0.53. What is the ratio of the Gross enrolment ratio (%) in Lao PDR in 1999 to that in 2004?
Your answer should be compact. 1.01. What is the ratio of the Gross enrolment ratio (%) of Yemen, Rep. in 1999 to that in 2004?
Offer a very short reply. 0.84. What is the ratio of the Gross enrolment ratio (%) of Small states in 1999 to that in 2005?
Provide a succinct answer. 0.96. What is the ratio of the Gross enrolment ratio (%) in Congo (Republic) in 1999 to that in 2005?
Offer a very short reply. 0.54. What is the ratio of the Gross enrolment ratio (%) of Lao PDR in 1999 to that in 2005?
Provide a succinct answer. 0.99. What is the ratio of the Gross enrolment ratio (%) of Yemen, Rep. in 1999 to that in 2005?
Ensure brevity in your answer.  0.82. What is the ratio of the Gross enrolment ratio (%) of Congo (Republic) in 1999 to that in 2008?
Keep it short and to the point. 0.56. What is the ratio of the Gross enrolment ratio (%) of Lao PDR in 1999 to that in 2008?
Give a very brief answer. 0.94. What is the ratio of the Gross enrolment ratio (%) in Yemen, Rep. in 1999 to that in 2008?
Offer a terse response. 0.81. What is the ratio of the Gross enrolment ratio (%) of Small states in 2001 to that in 2002?
Provide a short and direct response. 1. What is the ratio of the Gross enrolment ratio (%) in Congo (Republic) in 2001 to that in 2002?
Ensure brevity in your answer.  0.98. What is the ratio of the Gross enrolment ratio (%) of Yemen, Rep. in 2001 to that in 2002?
Offer a very short reply. 0.98. What is the ratio of the Gross enrolment ratio (%) of Small states in 2001 to that in 2003?
Provide a succinct answer. 0.99. What is the ratio of the Gross enrolment ratio (%) of Congo (Republic) in 2001 to that in 2003?
Provide a short and direct response. 1.03. What is the ratio of the Gross enrolment ratio (%) of Lao PDR in 2001 to that in 2003?
Provide a short and direct response. 0.97. What is the ratio of the Gross enrolment ratio (%) of Yemen, Rep. in 2001 to that in 2003?
Offer a terse response. 0.94. What is the ratio of the Gross enrolment ratio (%) of Small states in 2001 to that in 2004?
Ensure brevity in your answer.  0.99. What is the ratio of the Gross enrolment ratio (%) of Congo (Republic) in 2001 to that in 2004?
Provide a short and direct response. 0.93. What is the ratio of the Gross enrolment ratio (%) in Lao PDR in 2001 to that in 2004?
Your response must be concise. 0.96. What is the ratio of the Gross enrolment ratio (%) in Yemen, Rep. in 2001 to that in 2004?
Provide a short and direct response. 0.91. What is the ratio of the Gross enrolment ratio (%) in Small states in 2001 to that in 2005?
Your answer should be very brief. 0.99. What is the ratio of the Gross enrolment ratio (%) in Congo (Republic) in 2001 to that in 2005?
Provide a succinct answer. 0.93. What is the ratio of the Gross enrolment ratio (%) in Lao PDR in 2001 to that in 2005?
Provide a succinct answer. 0.94. What is the ratio of the Gross enrolment ratio (%) of Yemen, Rep. in 2001 to that in 2005?
Offer a terse response. 0.88. What is the ratio of the Gross enrolment ratio (%) of Small states in 2001 to that in 2008?
Offer a very short reply. 0.99. What is the ratio of the Gross enrolment ratio (%) of Congo (Republic) in 2001 to that in 2008?
Give a very brief answer. 0.98. What is the ratio of the Gross enrolment ratio (%) in Lao PDR in 2001 to that in 2008?
Give a very brief answer. 0.89. What is the ratio of the Gross enrolment ratio (%) in Yemen, Rep. in 2001 to that in 2008?
Your answer should be very brief. 0.88. What is the ratio of the Gross enrolment ratio (%) of Small states in 2002 to that in 2003?
Offer a terse response. 1. What is the ratio of the Gross enrolment ratio (%) in Congo (Republic) in 2002 to that in 2003?
Offer a terse response. 1.06. What is the ratio of the Gross enrolment ratio (%) of Lao PDR in 2002 to that in 2003?
Give a very brief answer. 0.98. What is the ratio of the Gross enrolment ratio (%) in Yemen, Rep. in 2002 to that in 2003?
Your answer should be very brief. 0.96. What is the ratio of the Gross enrolment ratio (%) in Small states in 2002 to that in 2004?
Provide a succinct answer. 0.99. What is the ratio of the Gross enrolment ratio (%) of Congo (Republic) in 2002 to that in 2004?
Keep it short and to the point. 0.95. What is the ratio of the Gross enrolment ratio (%) of Lao PDR in 2002 to that in 2004?
Make the answer very short. 0.97. What is the ratio of the Gross enrolment ratio (%) of Yemen, Rep. in 2002 to that in 2004?
Give a very brief answer. 0.93. What is the ratio of the Gross enrolment ratio (%) in Small states in 2002 to that in 2005?
Keep it short and to the point. 0.99. What is the ratio of the Gross enrolment ratio (%) in Congo (Republic) in 2002 to that in 2005?
Your response must be concise. 0.96. What is the ratio of the Gross enrolment ratio (%) of Lao PDR in 2002 to that in 2005?
Keep it short and to the point. 0.95. What is the ratio of the Gross enrolment ratio (%) of Yemen, Rep. in 2002 to that in 2005?
Keep it short and to the point. 0.9. What is the ratio of the Gross enrolment ratio (%) of Lao PDR in 2002 to that in 2008?
Ensure brevity in your answer.  0.9. What is the ratio of the Gross enrolment ratio (%) of Yemen, Rep. in 2002 to that in 2008?
Provide a short and direct response. 0.9. What is the ratio of the Gross enrolment ratio (%) in Small states in 2003 to that in 2004?
Offer a terse response. 1. What is the ratio of the Gross enrolment ratio (%) in Congo (Republic) in 2003 to that in 2004?
Give a very brief answer. 0.9. What is the ratio of the Gross enrolment ratio (%) in Lao PDR in 2003 to that in 2004?
Your answer should be compact. 0.99. What is the ratio of the Gross enrolment ratio (%) in Congo (Republic) in 2003 to that in 2005?
Ensure brevity in your answer.  0.9. What is the ratio of the Gross enrolment ratio (%) of Lao PDR in 2003 to that in 2005?
Give a very brief answer. 0.97. What is the ratio of the Gross enrolment ratio (%) of Yemen, Rep. in 2003 to that in 2005?
Keep it short and to the point. 0.94. What is the ratio of the Gross enrolment ratio (%) of Small states in 2003 to that in 2008?
Make the answer very short. 1. What is the ratio of the Gross enrolment ratio (%) of Congo (Republic) in 2003 to that in 2008?
Your answer should be very brief. 0.95. What is the ratio of the Gross enrolment ratio (%) of Lao PDR in 2003 to that in 2008?
Keep it short and to the point. 0.92. What is the ratio of the Gross enrolment ratio (%) in Yemen, Rep. in 2003 to that in 2008?
Keep it short and to the point. 0.93. What is the ratio of the Gross enrolment ratio (%) in Congo (Republic) in 2004 to that in 2005?
Keep it short and to the point. 1.01. What is the ratio of the Gross enrolment ratio (%) of Lao PDR in 2004 to that in 2005?
Ensure brevity in your answer.  0.98. What is the ratio of the Gross enrolment ratio (%) in Yemen, Rep. in 2004 to that in 2005?
Provide a short and direct response. 0.97. What is the ratio of the Gross enrolment ratio (%) of Congo (Republic) in 2004 to that in 2008?
Give a very brief answer. 1.06. What is the ratio of the Gross enrolment ratio (%) of Lao PDR in 2004 to that in 2008?
Offer a very short reply. 0.93. What is the ratio of the Gross enrolment ratio (%) in Yemen, Rep. in 2004 to that in 2008?
Provide a succinct answer. 0.97. What is the ratio of the Gross enrolment ratio (%) of Congo (Republic) in 2005 to that in 2008?
Make the answer very short. 1.05. What is the ratio of the Gross enrolment ratio (%) of Lao PDR in 2005 to that in 2008?
Your answer should be very brief. 0.94. What is the ratio of the Gross enrolment ratio (%) in Yemen, Rep. in 2005 to that in 2008?
Your answer should be very brief. 0.99. What is the difference between the highest and the second highest Gross enrolment ratio (%) of Small states?
Make the answer very short. 0.09. What is the difference between the highest and the second highest Gross enrolment ratio (%) in Congo (Republic)?
Provide a short and direct response. 0.96. What is the difference between the highest and the second highest Gross enrolment ratio (%) of Lao PDR?
Offer a terse response. 6.63. What is the difference between the highest and the second highest Gross enrolment ratio (%) in Yemen, Rep.?
Keep it short and to the point. 0.54. What is the difference between the highest and the lowest Gross enrolment ratio (%) in Small states?
Your answer should be compact. 4.01. What is the difference between the highest and the lowest Gross enrolment ratio (%) in Congo (Republic)?
Provide a short and direct response. 52.12. What is the difference between the highest and the lowest Gross enrolment ratio (%) of Lao PDR?
Your answer should be compact. 12.83. What is the difference between the highest and the lowest Gross enrolment ratio (%) in Yemen, Rep.?
Your answer should be compact. 16.82. 